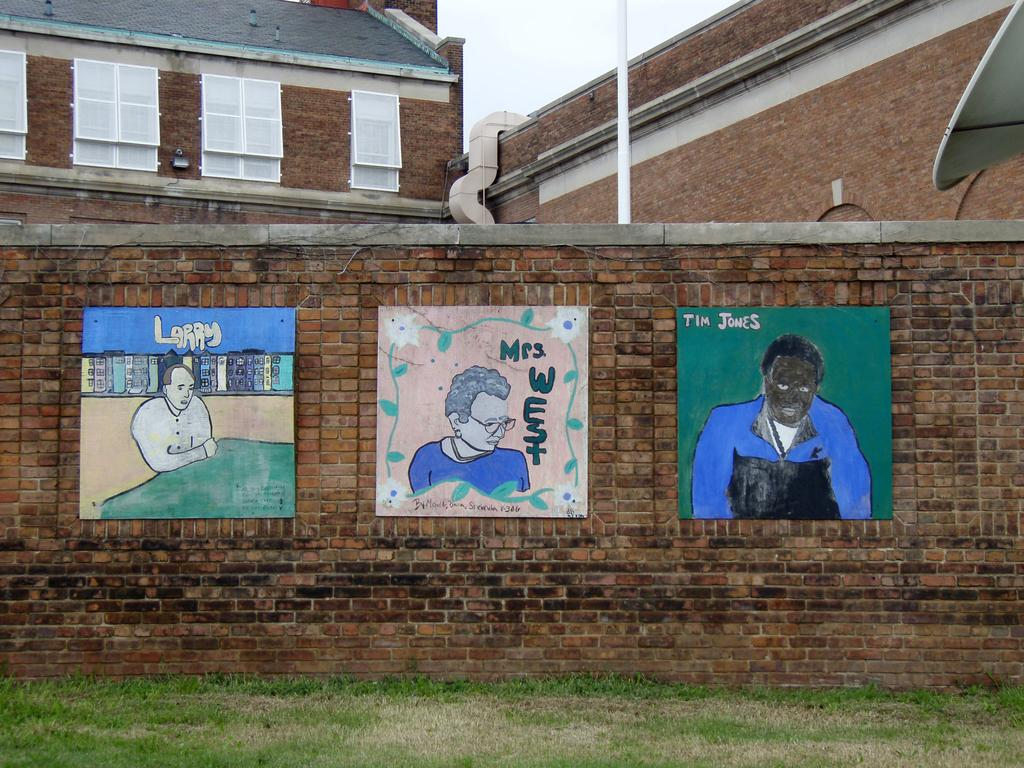What is hanging on the wall in the image? There is a group of pictures on the wall in the image. What can be seen in the background of the image? There is a building in the background of the image. What features of the building are visible? The building has windows, pipes, and a roof. What is visible in the sky in the background of the image? The sky is visible in the background of the image. How many oranges are hanging from the pipes on the building in the image? There are no oranges present in the image; the building has pipes, but they are not associated with any fruit. What type of debt is being discussed in the image? There is no mention of debt in the image; it features a group of pictures on the wall and a building in the background. 